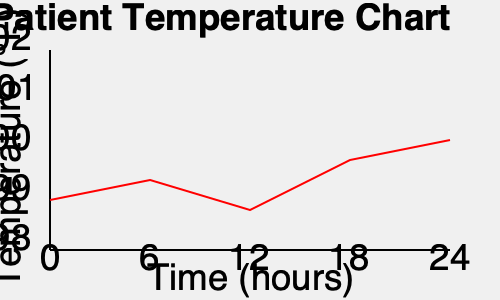As a medical student caring for a young actor awaiting surgery, you're monitoring their temperature over 24 hours. Based on the patient temperature chart, at what time does the patient's fever seem to peak, and what action should you consider taking? To answer this question, we need to analyze the patient temperature chart:

1. The x-axis represents time in hours, from 0 to 24.
2. The y-axis represents temperature in °F, from 98°F to 102°F.
3. The red line shows the patient's temperature over time.

Analyzing the chart:
1. The temperature starts at about 99°F at 0 hours.
2. It drops slightly at 6 hours.
3. At 12 hours, there's a significant spike, reaching about 100.5°F.
4. The temperature then decreases over the next 12 hours.

The fever peaks at the 12-hour mark, which is the highest point on the graph.

As a medical student, when a patient's fever peaks:
1. You should inform the supervising physician.
2. Consider administering fever-reducing medication (e.g., acetaminophen), if prescribed.
3. Ensure the patient is comfortable and well-hydrated.
4. Monitor for any additional symptoms or complications.
5. Reassess the patient's condition frequently.

Given the patient is awaiting surgery, it's crucial to keep the surgical team informed about this fever, as it might affect the timing or approach to the procedure.
Answer: 12 hours; inform physician and consider fever-reducing medication. 